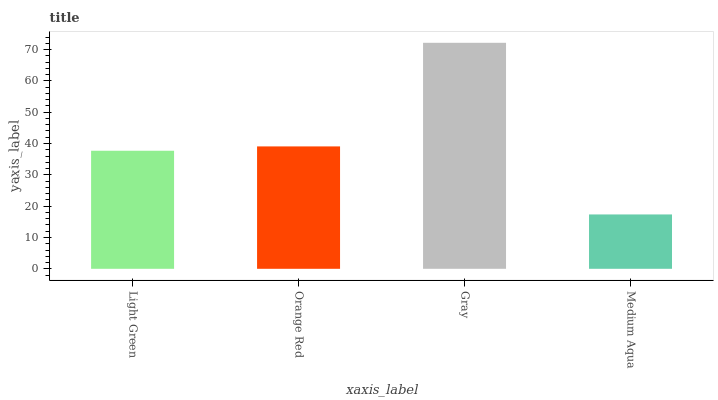Is Medium Aqua the minimum?
Answer yes or no. Yes. Is Gray the maximum?
Answer yes or no. Yes. Is Orange Red the minimum?
Answer yes or no. No. Is Orange Red the maximum?
Answer yes or no. No. Is Orange Red greater than Light Green?
Answer yes or no. Yes. Is Light Green less than Orange Red?
Answer yes or no. Yes. Is Light Green greater than Orange Red?
Answer yes or no. No. Is Orange Red less than Light Green?
Answer yes or no. No. Is Orange Red the high median?
Answer yes or no. Yes. Is Light Green the low median?
Answer yes or no. Yes. Is Gray the high median?
Answer yes or no. No. Is Orange Red the low median?
Answer yes or no. No. 